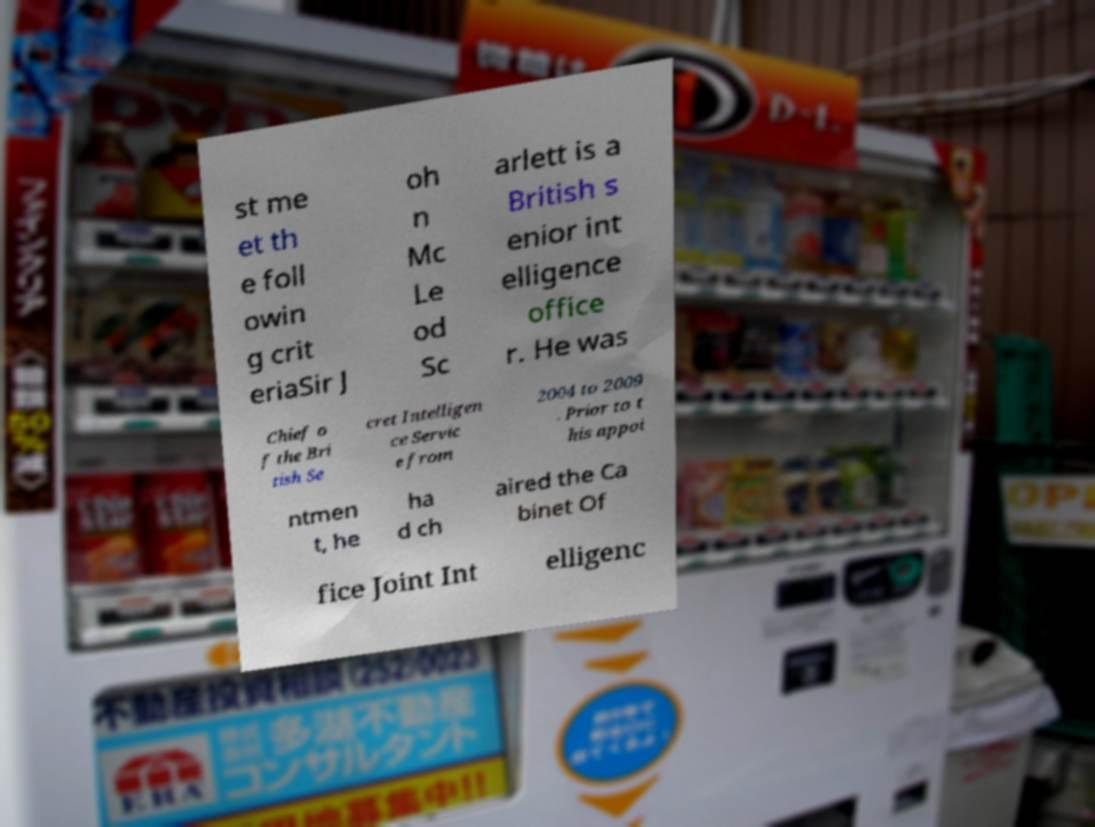Can you read and provide the text displayed in the image?This photo seems to have some interesting text. Can you extract and type it out for me? st me et th e foll owin g crit eriaSir J oh n Mc Le od Sc arlett is a British s enior int elligence office r. He was Chief o f the Bri tish Se cret Intelligen ce Servic e from 2004 to 2009 . Prior to t his appoi ntmen t, he ha d ch aired the Ca binet Of fice Joint Int elligenc 